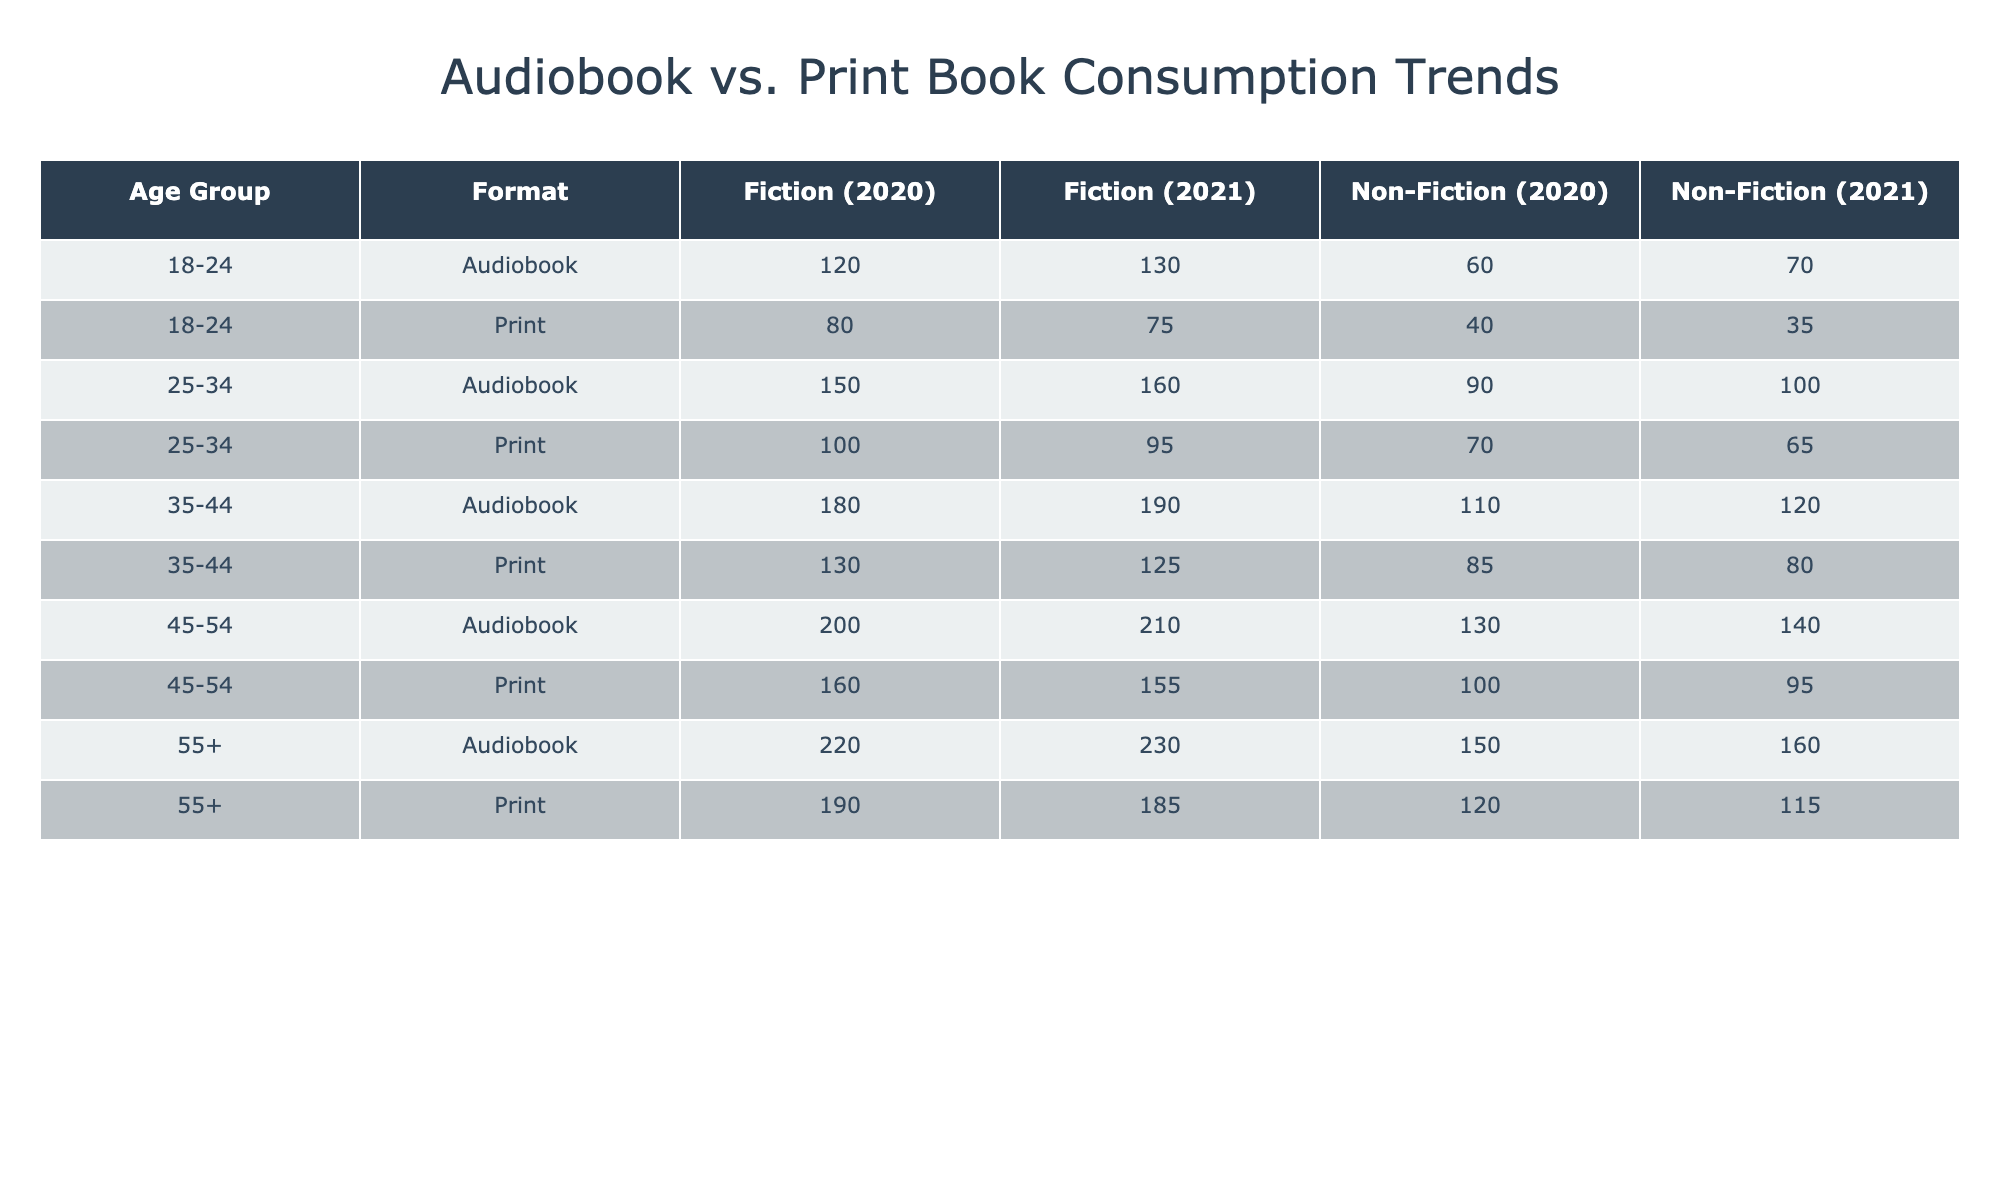What age group consumed the most hours of audiobooks in 2021? In 2021, according to the table, the age group 55+ consumed 230 hours of audiobooks, which is more than other age groups.
Answer: 55+ What is the total number of hours spent on print fiction across all age groups for the year 2020? To compute the total spent on print fiction in 2020, we look at each age group's hours: 80 (18-24) + 100 (25-34) + 130 (35-44) + 160 (45-54) + 190 (55+) = 660.
Answer: 660 Did the 18-24 age group consume more hours of audiobooks or print books in 2020? In 2020, the 18-24 age group consumed 120 hours of audiobooks and 80 hours of print books. Since 120 > 80, they consumed more audiobooks.
Answer: Yes What is the difference in hours consumed between audiobooks and print books for the 45-54 age group in 2021? For the 45-54 age group in 2021, audiobooks consumed were 210 hours and print books consumed were 155 hours. The difference is 210 - 155 = 55 hours.
Answer: 55 Which genre had the highest total hours consumed in audiobooks across all age groups for the year 2020? Calculating the total hours for each genre in audiobooks in 2020: Fiction sums to 120 + 150 + 180 + 200 + 220 = 1080 hours; Non-Fiction sums to 60 + 90 + 110 + 130 + 150 = 540 hours. Therefore, Fiction has the highest consumption.
Answer: Fiction How many more hours were consumed in audio non-fiction compared to print non-fiction for the age group 35-44 in 2021? For the age group 35-44 in 2021, audiobooks for non-fiction consumed were 120 hours and print non-fiction consumed were 80 hours. Thus, 120 - 80 = 40 hours more were consumed in audiobooks.
Answer: 40 Is it true that the favorite authors among audiobook listeners are the same as those among print book readers for the 25-34 age group in 2020? The favorite authors in audiobooks for 25-34 are Stephen King and Brené Brown, while for print, they are George Orwell and Simon Sinek. Since the authors differ, the statement is false.
Answer: No What was the average hours consumed for all audiobooks among all age groups in 2021? Summing the hours of audiobooks in 2021 gives us: 130 + 160 + 190 + 210 + 230 = 1020 hours. There are 5 age groups, so the average is 1020 / 5 = 204 hours.
Answer: 204 